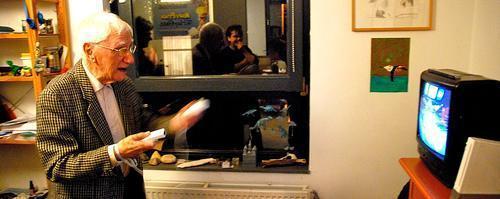How many people are wearing orange vests?
Give a very brief answer. 0. 